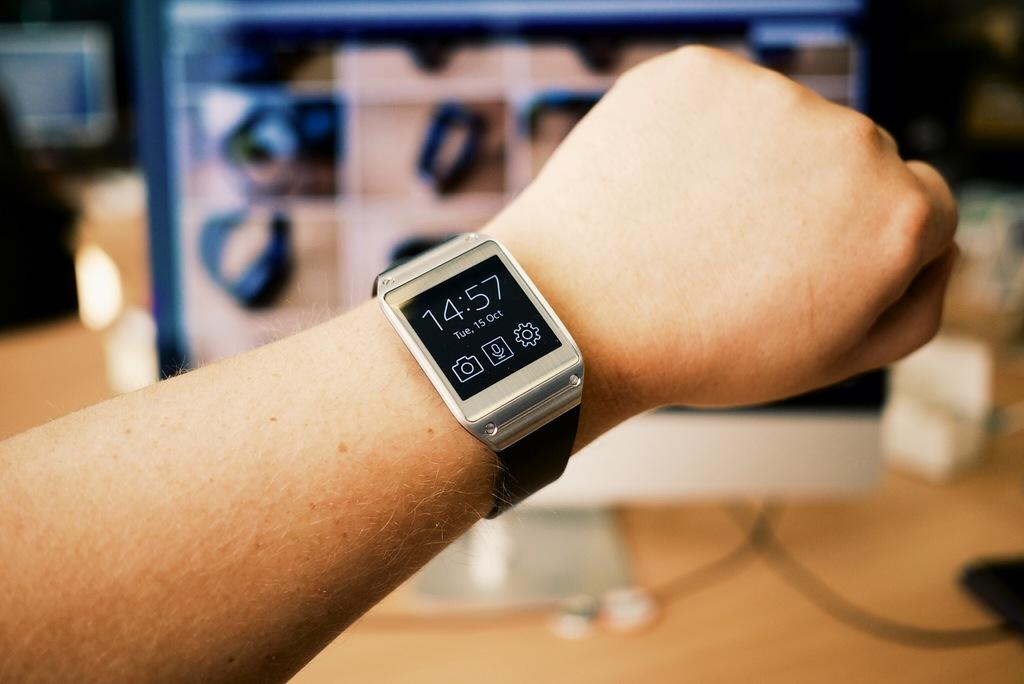<image>
Render a clear and concise summary of the photo. A watch displays the date as October fifteenth. 